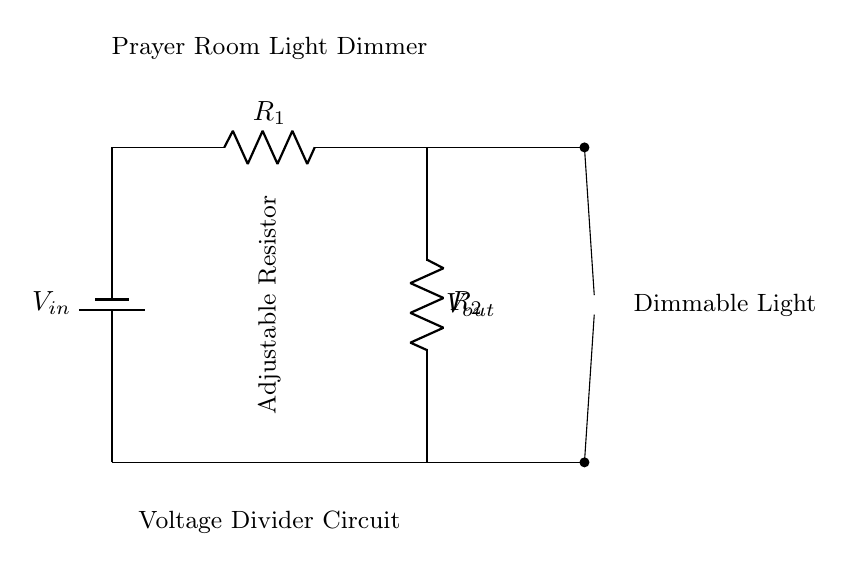What is the input voltage in the circuit? The circuit shows a battery labeled as V_in, indicating the input voltage source. This is where the voltage is supplied to the circuit.
Answer: V_in What are the resistances present in the circuit? The circuit includes two resistors labeled R_1 and R_2. These resistors are essential for forming the voltage divider, controlling the voltage output.
Answer: R_1, R_2 What type of component is depicted in the circuit for output? The circuit shows a lamp connected at the output, which indicates that it is used to visualize the dimming effect when the voltage is varied.
Answer: Lamp What happens to the light as the resistance is adjusted? Adjusting the resistance impacts the voltage across the lamp, thus changing its brightness. A higher resistance results in lesser voltage to the lamp, thereby dimming it.
Answer: Dims What does V_out represent in the circuit? V_out is the output voltage measured across the lamp. This voltage will change based on the values of R_1 and R_2, affecting the lamp's brightness.
Answer: Output voltage How does the configuration of resistors affect the voltage divider? The ratio of R_1 to R_2 determines how the input voltage is split between the two resistors, which directly influences the output voltage and, consequently, the lamp's brightness.
Answer: Voltage ratio What is the purpose of the adjustable resistor in this circuit? The adjustable resistor allows for variable resistance, enabling users to change the brightness of the lamp by altering the output voltage across it, making it a dynamic dimmer.
Answer: Light dimming 